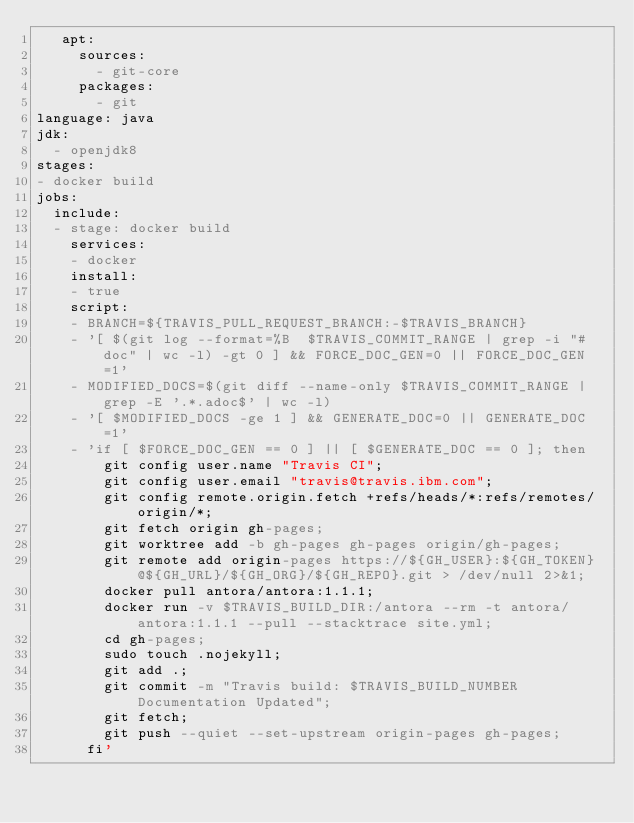Convert code to text. <code><loc_0><loc_0><loc_500><loc_500><_YAML_>   apt:
     sources:
       - git-core
     packages:
       - git
language: java
jdk:
  - openjdk8
stages:
- docker build
jobs:
  include:
  - stage: docker build
    services:
    - docker
    install:
    - true
    script:
    - BRANCH=${TRAVIS_PULL_REQUEST_BRANCH:-$TRAVIS_BRANCH}
    - '[ $(git log --format=%B  $TRAVIS_COMMIT_RANGE | grep -i "#doc" | wc -l) -gt 0 ] && FORCE_DOC_GEN=0 || FORCE_DOC_GEN=1'
    - MODIFIED_DOCS=$(git diff --name-only $TRAVIS_COMMIT_RANGE | grep -E '.*.adoc$' | wc -l)
    - '[ $MODIFIED_DOCS -ge 1 ] && GENERATE_DOC=0 || GENERATE_DOC=1'
    - 'if [ $FORCE_DOC_GEN == 0 ] || [ $GENERATE_DOC == 0 ]; then
        git config user.name "Travis CI";
        git config user.email "travis@travis.ibm.com";
        git config remote.origin.fetch +refs/heads/*:refs/remotes/origin/*;
        git fetch origin gh-pages;
        git worktree add -b gh-pages gh-pages origin/gh-pages;
        git remote add origin-pages https://${GH_USER}:${GH_TOKEN}@${GH_URL}/${GH_ORG}/${GH_REPO}.git > /dev/null 2>&1;
        docker pull antora/antora:1.1.1;
        docker run -v $TRAVIS_BUILD_DIR:/antora --rm -t antora/antora:1.1.1 --pull --stacktrace site.yml;
        cd gh-pages;
        sudo touch .nojekyll;
        git add .;
        git commit -m "Travis build: $TRAVIS_BUILD_NUMBER Documentation Updated";
        git fetch;
        git push --quiet --set-upstream origin-pages gh-pages;
      fi'
</code> 